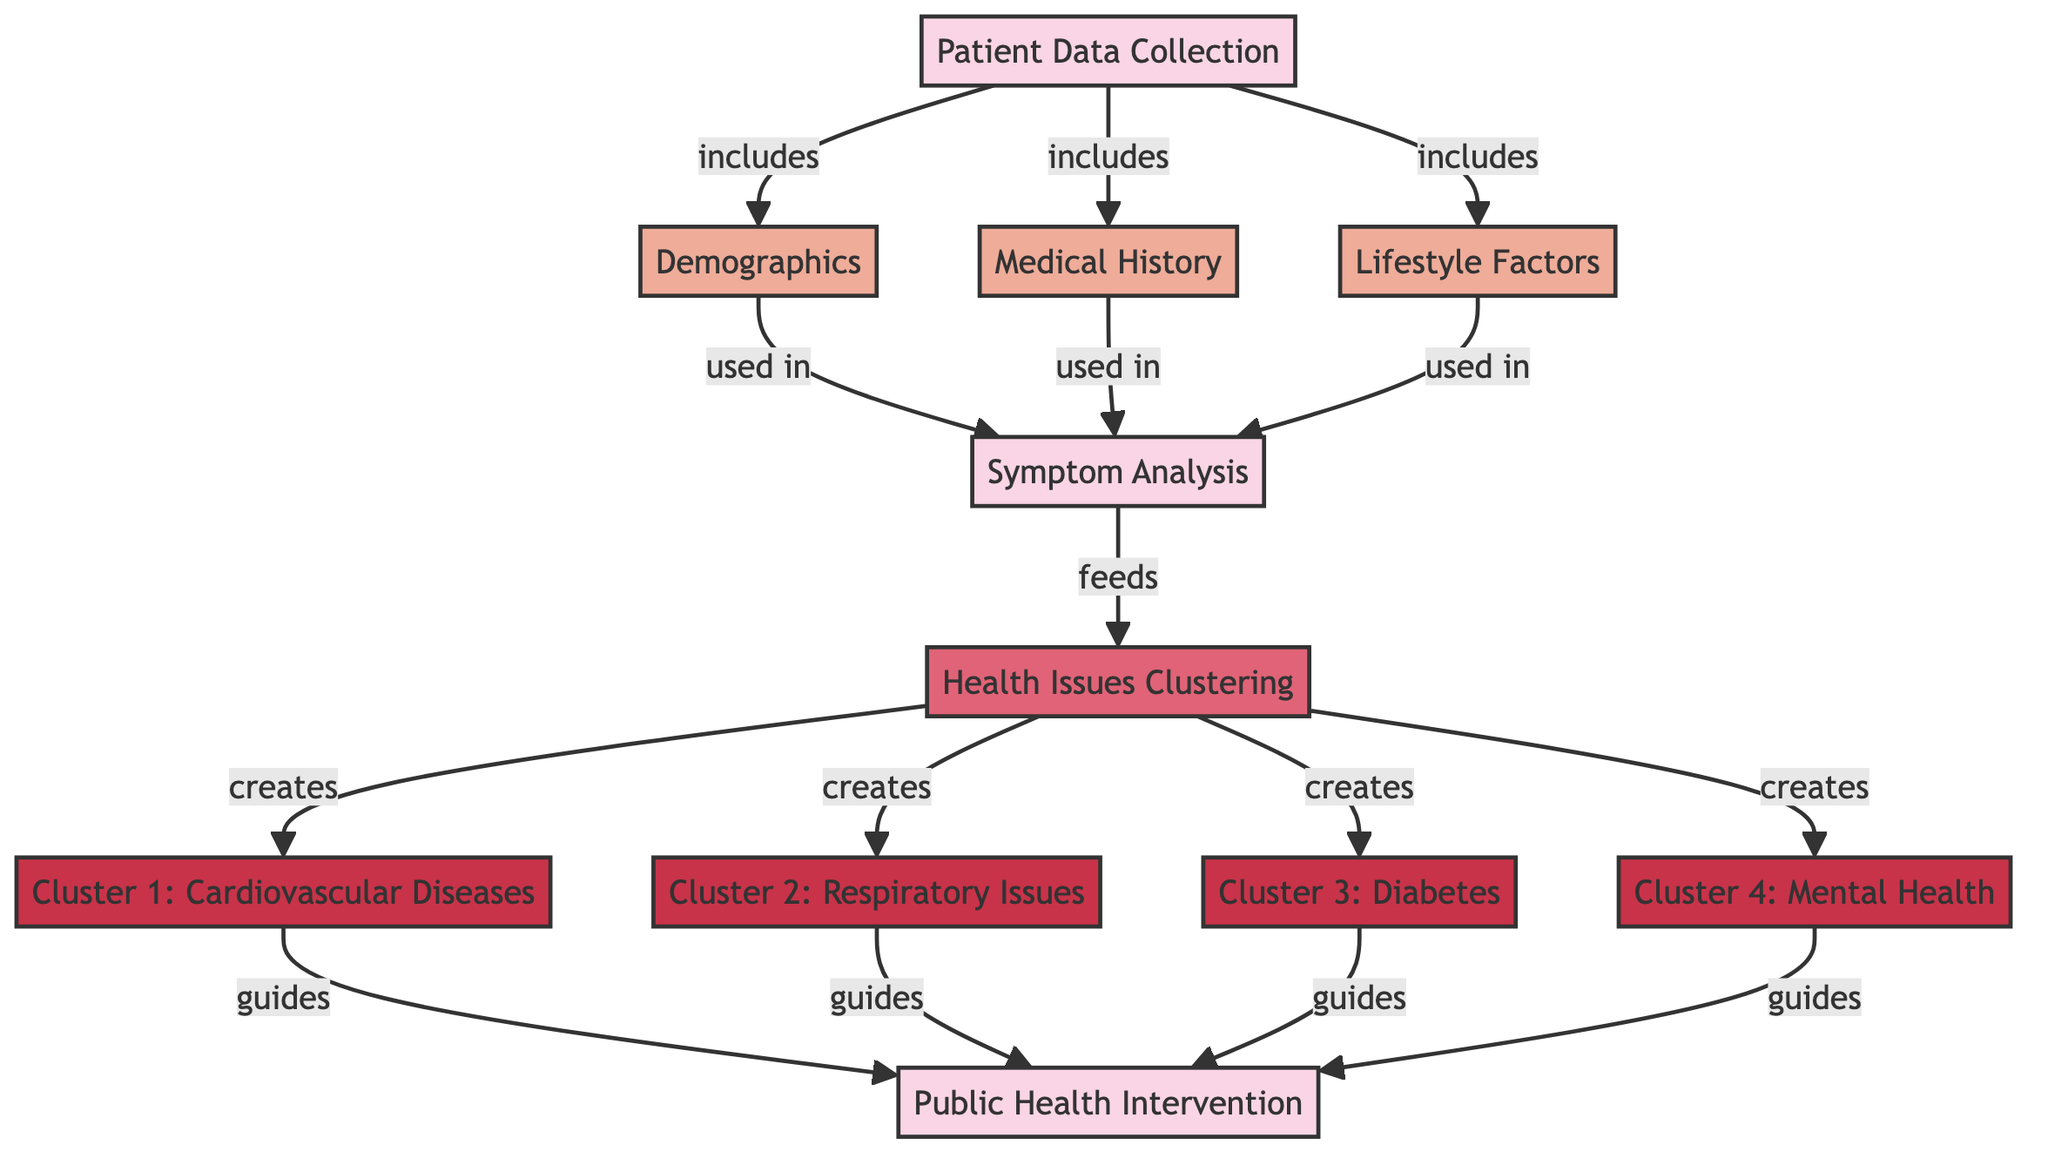What is the first step in the diagram? The first step in the diagram is "Patient Data Collection," as indicated by the flow from the initial process node.
Answer: Patient Data Collection How many output clusters are created from health issues clustering? The diagram shows four output clusters created as a result of the health issues clustering process, labeled Cluster 1 to Cluster 4.
Answer: Four Which node feeds into the health issues clustering? The node that feeds into the health issues clustering is "Symptom Analysis," as denoted by the directional arrow leading to the clustering algorithm.
Answer: Symptom Analysis What type of diseases is in Cluster 1? Cluster 1 contains "Cardiovascular Diseases," which is explicitly labeled as one of the output clusters resulting from the clustering process.
Answer: Cardiovascular Diseases How does "Demographics" relate to "Symptom Analysis"? "Demographics" is used in "Symptom Analysis," indicated by the arrow directed from the demographics node to the symptom analysis process, showing its contribution to analyzing symptoms.
Answer: Used in What guides the public health intervention process? The public health intervention process is guided by all four clusters generated from health issues clustering, specifically the clusters for cardiovascular diseases, respiratory issues, diabetes, and mental health, as shown by arrows leading from each cluster to the public health intervention.
Answer: All clusters What are the lifestyle factors included in the patient data collection? The diagram includes "Lifestyle Factors" as part of the patient data collection process, as this is specifically noted as one of the inputs.
Answer: Lifestyle Factors How many nodes depict health issue clusters? There are four nodes that depict health issue clusters, corresponding to the labels for Cluster 1 through Cluster 4.
Answer: Four What is the role of medical history in the diagram? The medical history node is included in the patient data collection and is used as part of the symptom analysis to inform the clustering process, as indicated by the arrows in the diagram.
Answer: Used in Which cluster is associated with mental health issues? Cluster 4 is associated with "Mental Health," as clearly indicated in the output section of the diagram.
Answer: Mental Health 